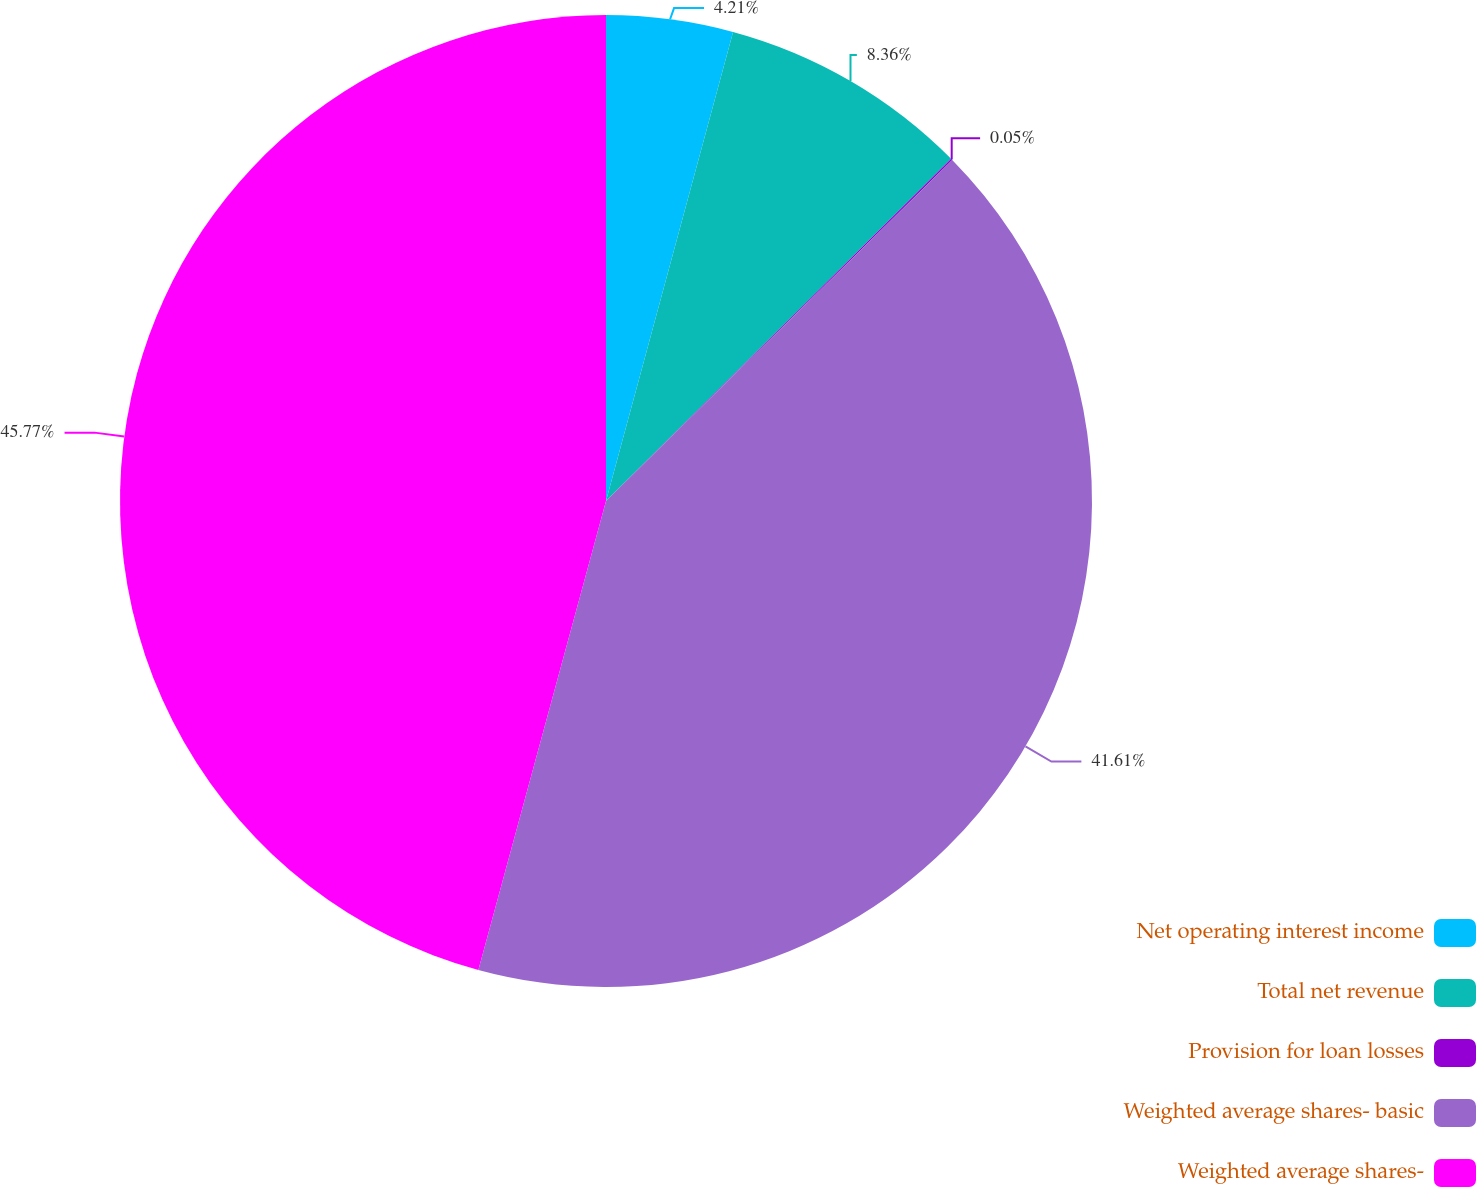Convert chart to OTSL. <chart><loc_0><loc_0><loc_500><loc_500><pie_chart><fcel>Net operating interest income<fcel>Total net revenue<fcel>Provision for loan losses<fcel>Weighted average shares- basic<fcel>Weighted average shares-<nl><fcel>4.21%<fcel>8.36%<fcel>0.05%<fcel>41.61%<fcel>45.77%<nl></chart> 